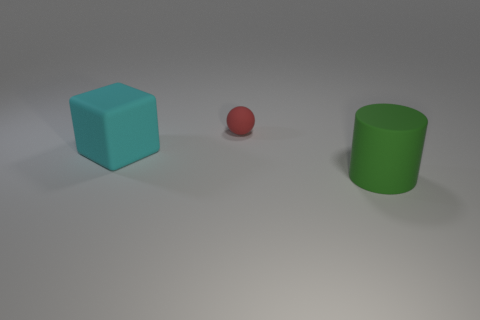What might be the function of these objects in a real-world setting? In a real-world setting, these objects could serve various purposes. The blue cube could be a child's toy block or perhaps a seat if it's sturdy. The red sphere might be a ball for play or decoration. The green cylinder resembles a container or a waste bin depending on its material and size scale. Are these objects to scale with one another? Without additional context, it's challenging to determine the absolute scale, but relative to each other, the objects maintain a consistent scale. The cube and cylinder are both larger than the sphere, suggesting they could belong to a set or collection designed to fit together. 